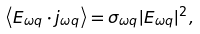<formula> <loc_0><loc_0><loc_500><loc_500>\left \langle E _ { \omega q } \cdot j _ { \omega q } \right \rangle = \sigma _ { \omega q } | E _ { \omega q } | ^ { 2 } ,</formula> 